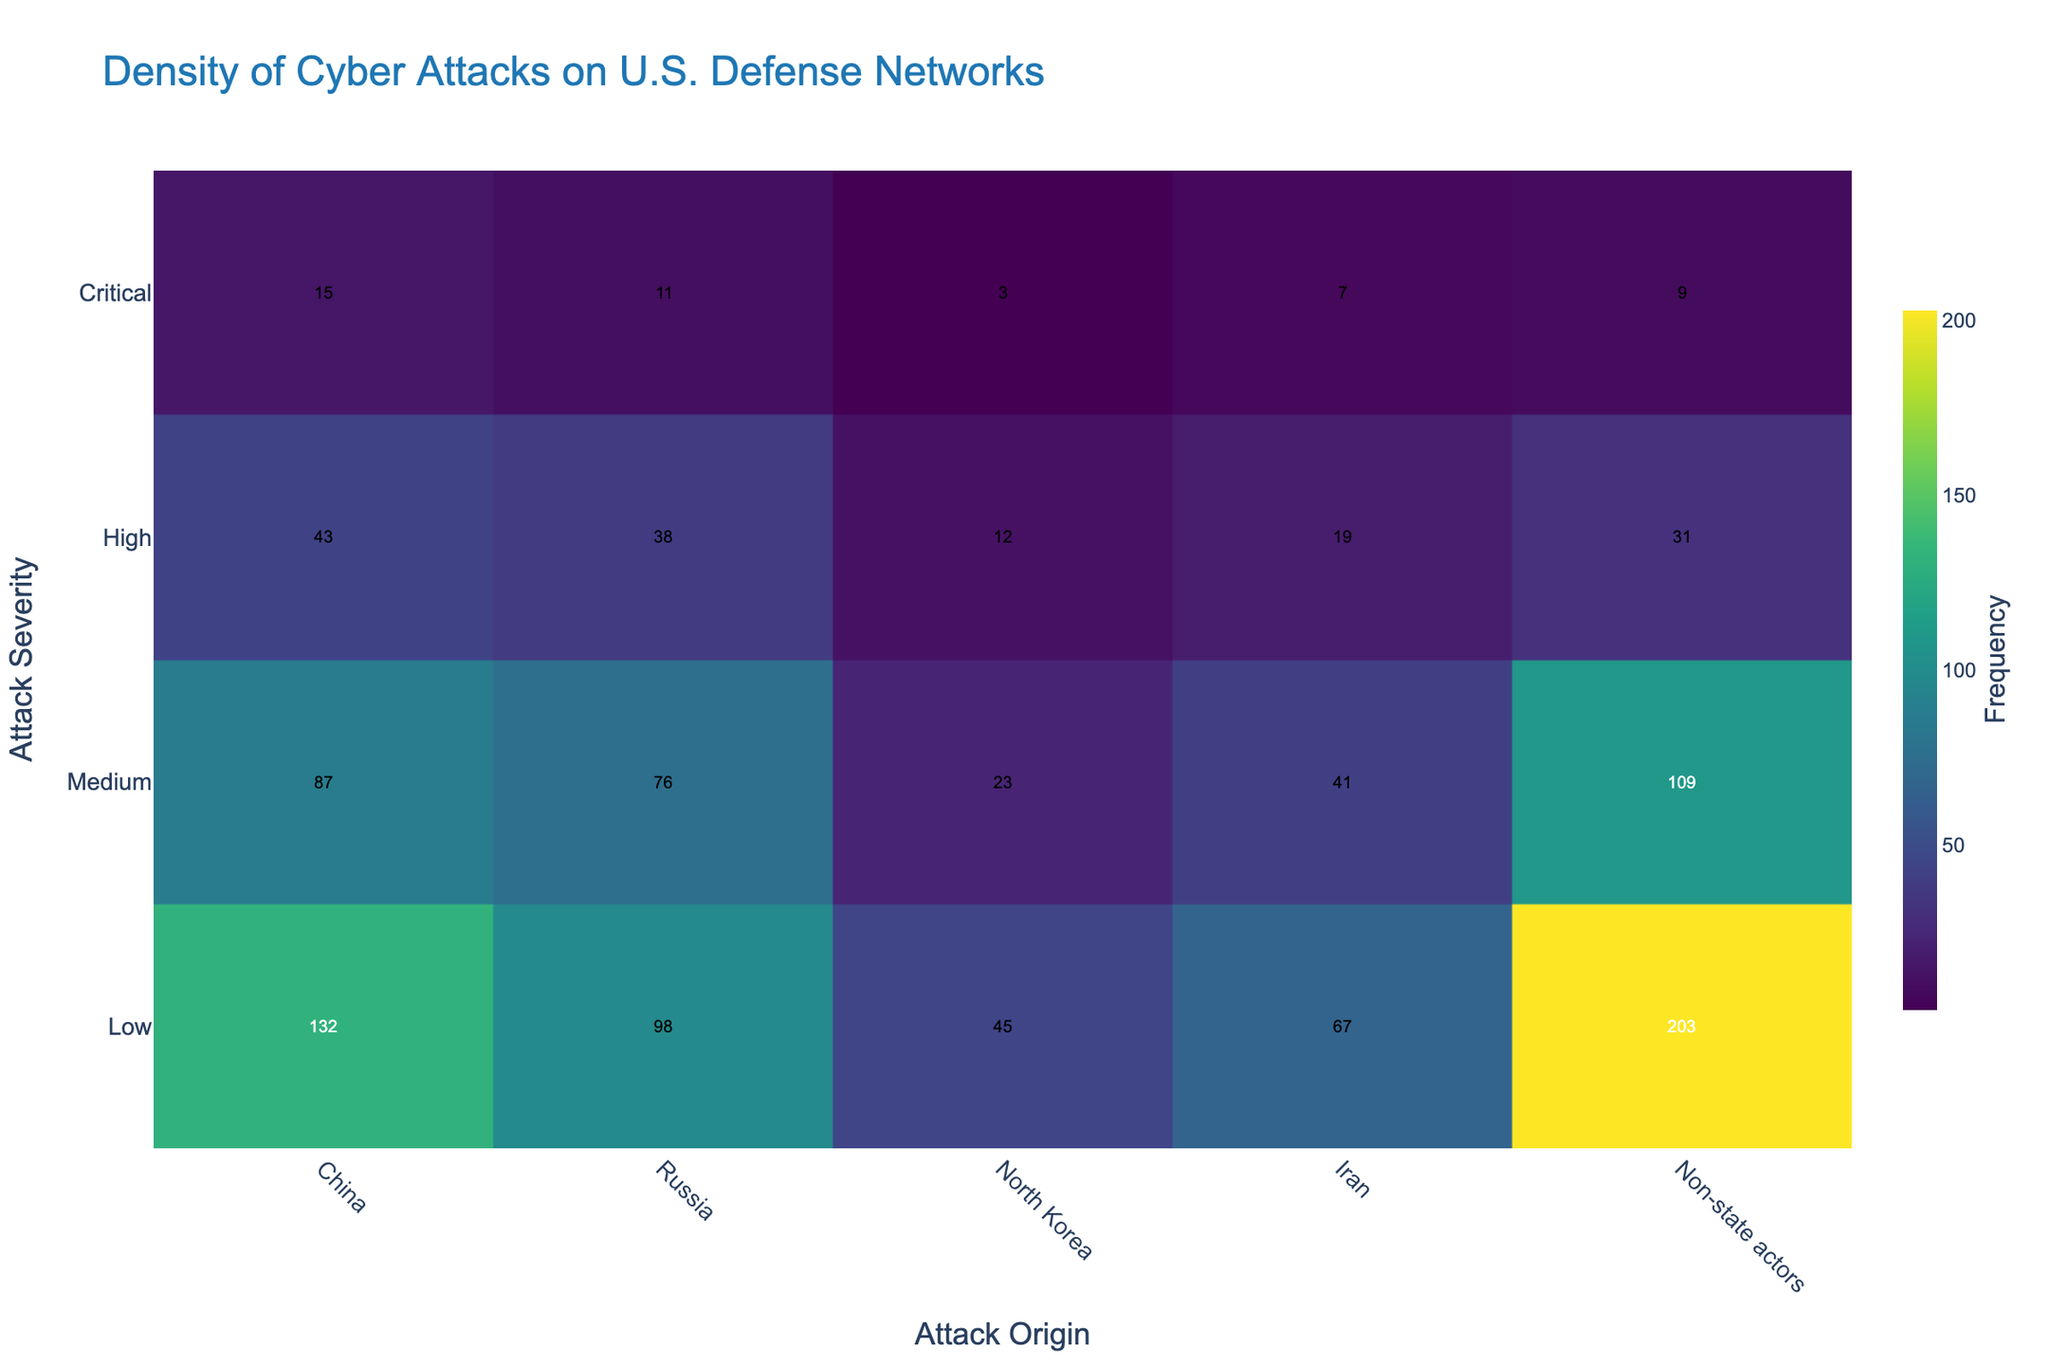What's the title of the plot? The title of the plot is displayed at the top of the figure and reads "Density of Cyber Attacks on U.S. Defense Networks."
Answer: Density of Cyber Attacks on U.S. Defense Networks Which origin has the highest frequency of critical severity cyber attacks? By analyzing the density plot, the color intensity of the "Critical" severity level is highest for "China," indicating it has the highest frequency in this category.
Answer: China How many total medium severity cyber attacks are recorded? Sum the frequencies for the "Medium" severity across all origins: 87 (China) + 76 (Russia) + 23 (North Korea) + 41 (Iran) + 109 (Non-state actors) = 336.
Answer: 336 Which origin has the lowest frequency of low severity cyber attacks? By comparing the color intensity and annotations for "Low" severity across origins, "North Korea" has the lowest frequency with a value of 45.
Answer: North Korea What is the average frequency of high severity cyber attacks from state actors (China, Russia, North Korea, Iran)? Add the frequencies of high severity attacks from China (43), Russia (38), North Korea (12), and Iran (19), then divide by 4: (43 + 38 + 12 + 19) / 4 = 28.
Answer: 28 Compare the frequency of low severity attacks from Non-state actors with the frequency from state actors (China, Russia, North Korea, Iran) combined. Calculate and compare:
Non-state actors: 203,
State actors: 132 (China) + 98 (Russia) + 45 (North Korea) + 67 (Iran) = 342.
Non-state actors have fewer attacks compared to state actors combined (203 vs. 342).
Answer: Non-state actors have fewer Which severity level has the highest overall frequency for cyber attacks? By summing the frequencies across all origins for each severity level:
Low: 545, Medium: 336, High: 143, Critical: 45.
Low severity has the highest overall frequency with a total of 545.
Answer: Low What is the difference in the frequency of medium severity cyber attacks between China and Russia? Subtract the frequency of medium severity attacks from Russia (76) from China's (87): 87 - 76 = 11.
Answer: 11 Which origin has more high severity attacks, Iran or Non-state actors? Compare the frequency annotations directly:
Iran: 19, Non-state actors: 31.
Non-state actors have more high severity attacks.
Answer: Non-state actors Is the density of cyber attacks more evenly distributed across origins for low severity or critical severity? By observing the variance in color intensity and annotations for both severities:
Low severity shows a more evenly distributed frequency among origins (ranging from 45 to 203) compared to critical severity (ranging from 3 to 15).
Low severity has a more evenly distributed density.
Answer: Low severity 